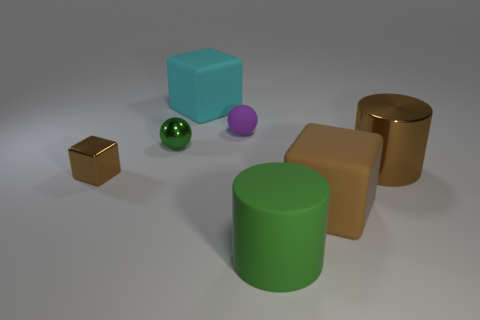What is the material of the large cube that is the same color as the shiny cylinder?
Your response must be concise. Rubber. Is there a sphere of the same color as the small rubber object?
Provide a succinct answer. No. Is there anything else that is the same size as the cyan rubber object?
Provide a succinct answer. Yes. How many big objects are the same color as the tiny cube?
Keep it short and to the point. 2. There is a tiny cube; is it the same color as the cylinder that is in front of the large metal thing?
Make the answer very short. No. What number of objects are tiny gray metallic cylinders or big things behind the big matte cylinder?
Offer a very short reply. 3. How big is the block that is left of the ball that is to the left of the cyan thing?
Provide a succinct answer. Small. Is the number of tiny green balls to the left of the small green object the same as the number of large cyan rubber blocks that are right of the large cyan matte cube?
Your response must be concise. Yes. There is a brown object on the left side of the large cyan cube; is there a large cyan matte object that is in front of it?
Make the answer very short. No. There is a tiny green object that is the same material as the brown cylinder; what shape is it?
Give a very brief answer. Sphere. 